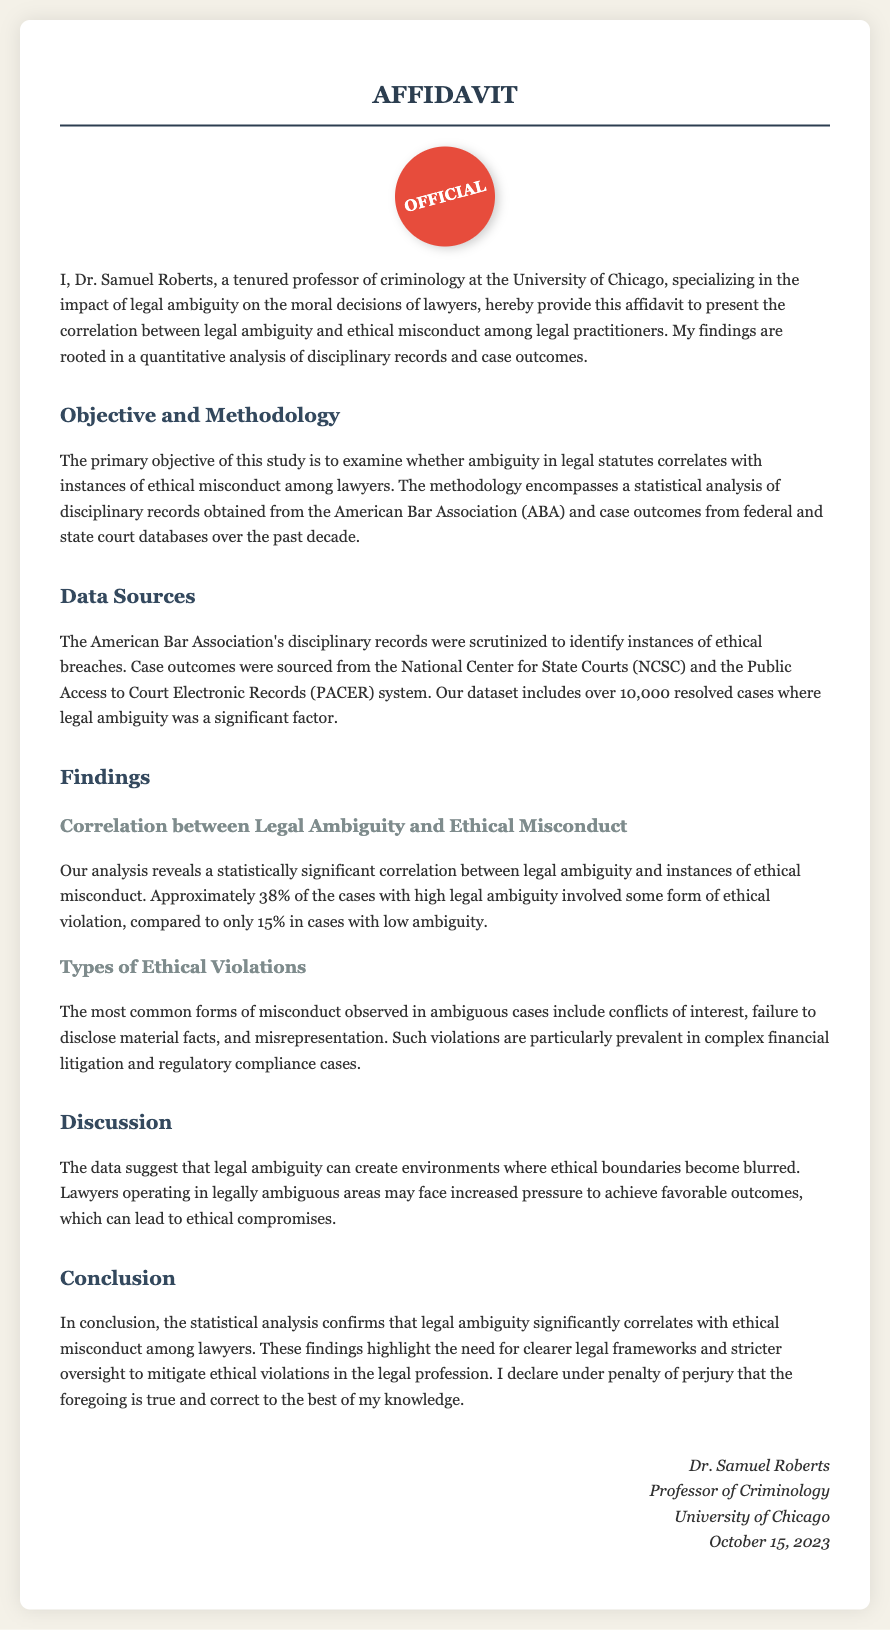What is the name of the author of the affidavit? The name of the author is presented in the opening paragraph of the document, identified as Dr. Samuel Roberts.
Answer: Dr. Samuel Roberts What university is Dr. Samuel Roberts affiliated with? The university affiliation of Dr. Samuel Roberts is stated in the first paragraph of the document, which mentions the University of Chicago.
Answer: University of Chicago What percentage of high ambiguity cases involved ethical violations? The percentage of high ambiguity cases involving ethical violations is given as approximately 38% in the findings section.
Answer: 38% What is the date the affidavit was signed? The date on which the affidavit was signed can be found in the signature section at the bottom of the document, indicating October 15, 2023.
Answer: October 15, 2023 What common form of misconduct is noted in ambiguous cases? The findings section specifies that conflicts of interest are one of the most common forms of misconduct observed in ambiguous cases.
Answer: Conflicts of interest How many resolved cases were included in the dataset? The document mentions that the dataset includes over 10,000 resolved cases, as stated in the Data Sources section.
Answer: 10,000 What is the primary objective of the study? The objective is described in the Objective and Methodology section, stating that it is to examine whether ambiguity in legal statutes correlates with instances of ethical misconduct among lawyers.
Answer: Correlate legal ambiguity with ethical misconduct What type of document is this? The title of the document is presented clearly at the top as "AFFIDAVIT," indicating its type.
Answer: AFFIDAVIT What does the statistical analysis confirm about legal ambiguity? The conclusion section of the document asserts that the statistical analysis confirms a significant correlation between legal ambiguity and ethical misconduct among lawyers.
Answer: Significant correlation 